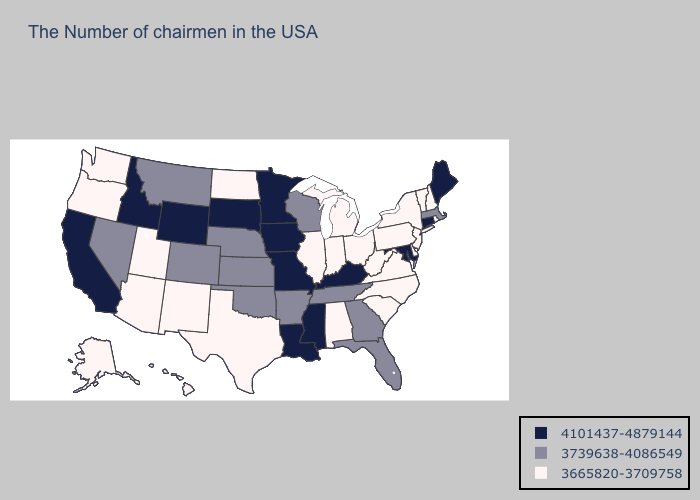What is the lowest value in the Northeast?
Quick response, please. 3665820-3709758. Which states have the lowest value in the USA?
Short answer required. Rhode Island, New Hampshire, Vermont, New York, New Jersey, Delaware, Pennsylvania, Virginia, North Carolina, South Carolina, West Virginia, Ohio, Michigan, Indiana, Alabama, Illinois, Texas, North Dakota, New Mexico, Utah, Arizona, Washington, Oregon, Alaska, Hawaii. Which states have the lowest value in the USA?
Keep it brief. Rhode Island, New Hampshire, Vermont, New York, New Jersey, Delaware, Pennsylvania, Virginia, North Carolina, South Carolina, West Virginia, Ohio, Michigan, Indiana, Alabama, Illinois, Texas, North Dakota, New Mexico, Utah, Arizona, Washington, Oregon, Alaska, Hawaii. Name the states that have a value in the range 3739638-4086549?
Keep it brief. Massachusetts, Florida, Georgia, Tennessee, Wisconsin, Arkansas, Kansas, Nebraska, Oklahoma, Colorado, Montana, Nevada. What is the highest value in the Northeast ?
Answer briefly. 4101437-4879144. What is the value of Hawaii?
Concise answer only. 3665820-3709758. Among the states that border Arizona , does California have the lowest value?
Concise answer only. No. Among the states that border Indiana , which have the lowest value?
Answer briefly. Ohio, Michigan, Illinois. Is the legend a continuous bar?
Concise answer only. No. Among the states that border Rhode Island , which have the lowest value?
Give a very brief answer. Massachusetts. Name the states that have a value in the range 3739638-4086549?
Give a very brief answer. Massachusetts, Florida, Georgia, Tennessee, Wisconsin, Arkansas, Kansas, Nebraska, Oklahoma, Colorado, Montana, Nevada. What is the value of North Dakota?
Write a very short answer. 3665820-3709758. What is the highest value in the USA?
Give a very brief answer. 4101437-4879144. How many symbols are there in the legend?
Give a very brief answer. 3. 